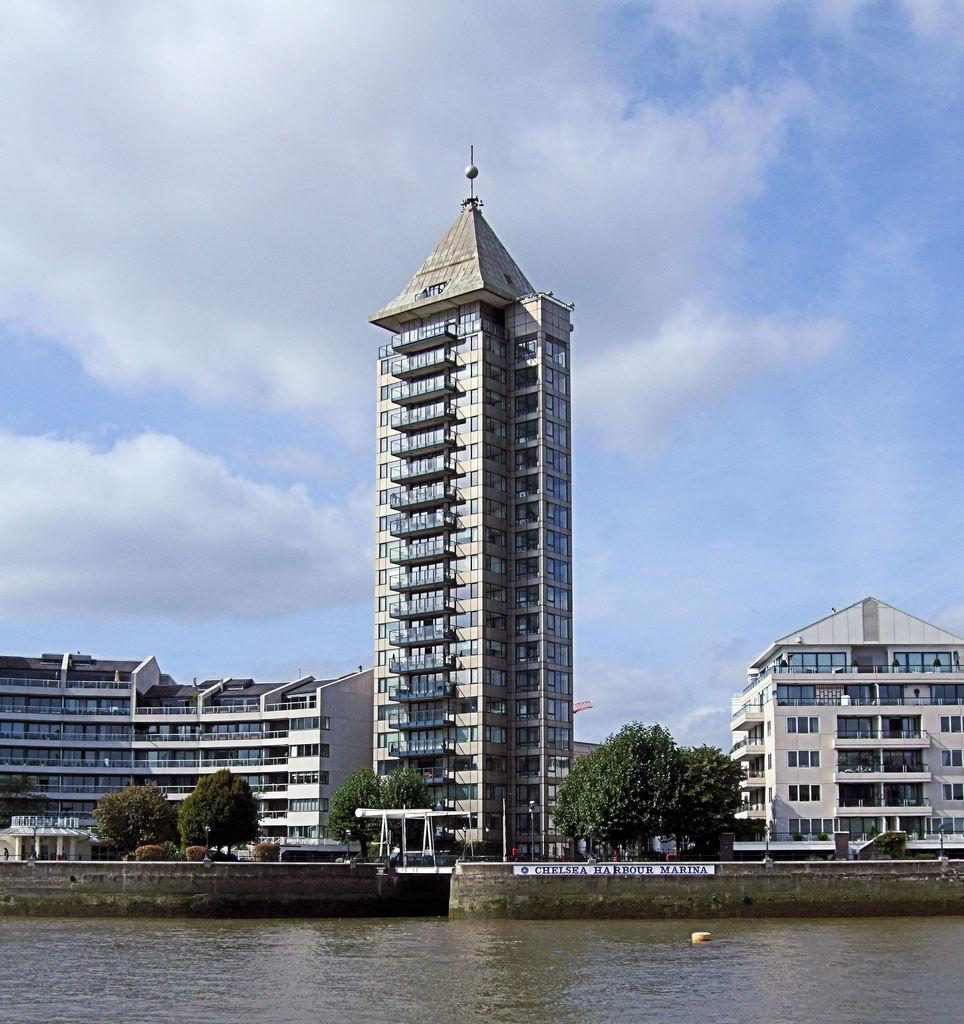What type of structures can be seen in the image? There are buildings in the image, including a skyscraper. What is being used for construction purposes in the image? There is a construction crane in the image. What type of vegetation is present in the image? There are trees in the image. What type of transportation is visible in the image? There are motor vehicles on the road in the image. What natural elements can be seen in the image? There is water and sky visible in the image, with clouds in the sky. Where is the table located in the image? There is no table present in the image. How much money is being exchanged between the people in the image? There are no people or money exchanges depicted in the image. 